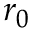<formula> <loc_0><loc_0><loc_500><loc_500>r _ { 0 }</formula> 